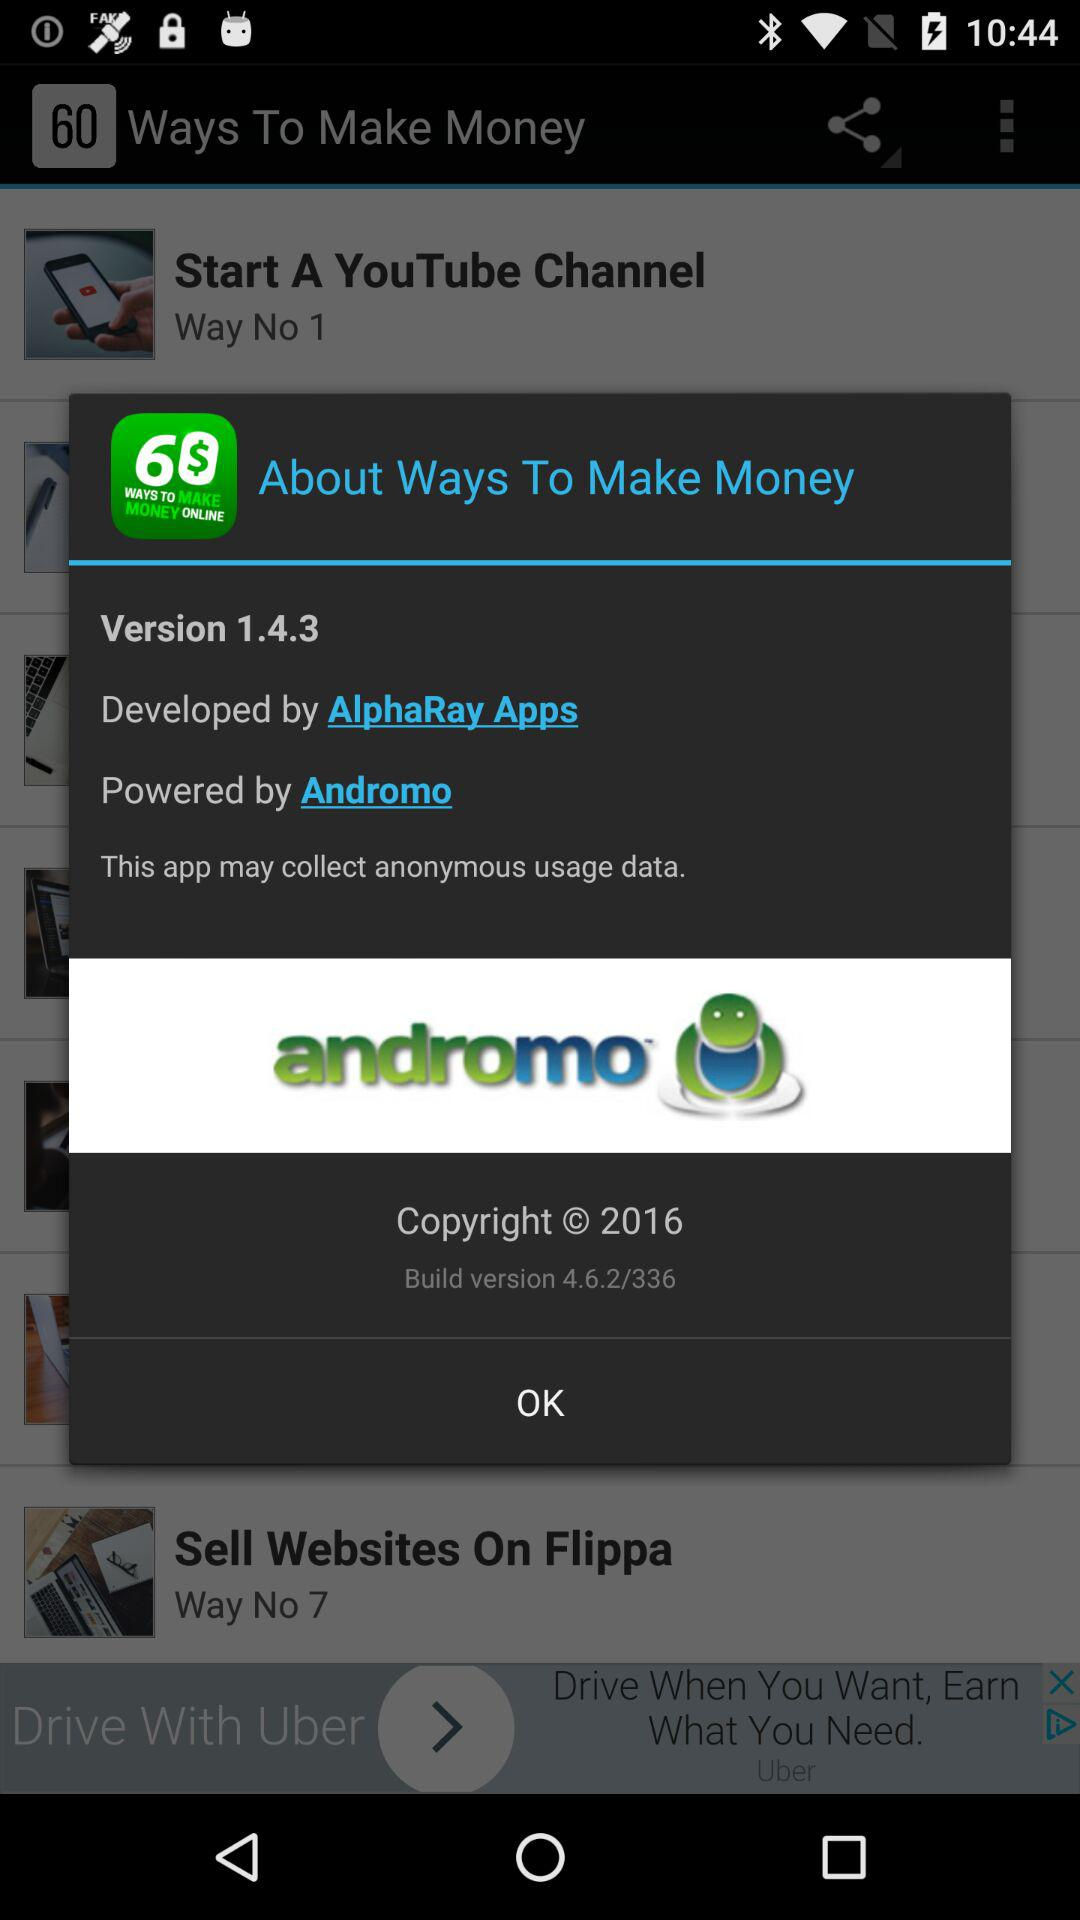Who is the developer? The developer is AlphaRay Apps. 